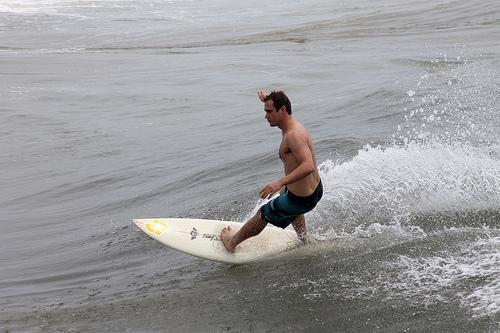Question: where is the man?
Choices:
A. By a lake.
B. In the mountains.
C. The ocean.
D. On a hillside.
Answer with the letter. Answer: C Question: why is the man on a surfboard?
Choices:
A. For exercise.
B. He's taking a lesson.
C. He is surfing.
D. He's practicing.
Answer with the letter. Answer: C Question: what is the man wearing?
Choices:
A. Wetsuit.
B. Board shorts.
C. Speedo.
D. Jean shorts.
Answer with the letter. Answer: B Question: when is it?
Choices:
A. Day time.
B. Night time.
C. Dusk.
D. Very early morning.
Answer with the letter. Answer: A Question: who is on the surfboard?
Choices:
A. The man.
B. A woman.
C. A kid.
D. Two teenagers.
Answer with the letter. Answer: A 